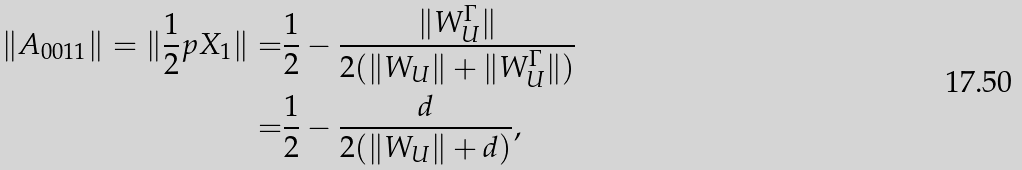Convert formula to latex. <formula><loc_0><loc_0><loc_500><loc_500>\| A _ { 0 0 1 1 } \| = \| \frac { 1 } { 2 } p X _ { 1 } \| = & \frac { 1 } { 2 } - \frac { \| W _ { U } ^ { \Gamma } \| } { 2 ( \| W _ { U } \| + \| W _ { U } ^ { \Gamma } \| ) } \\ = & \frac { 1 } { 2 } - \frac { d } { 2 ( \| W _ { U } \| + d ) } ,</formula> 